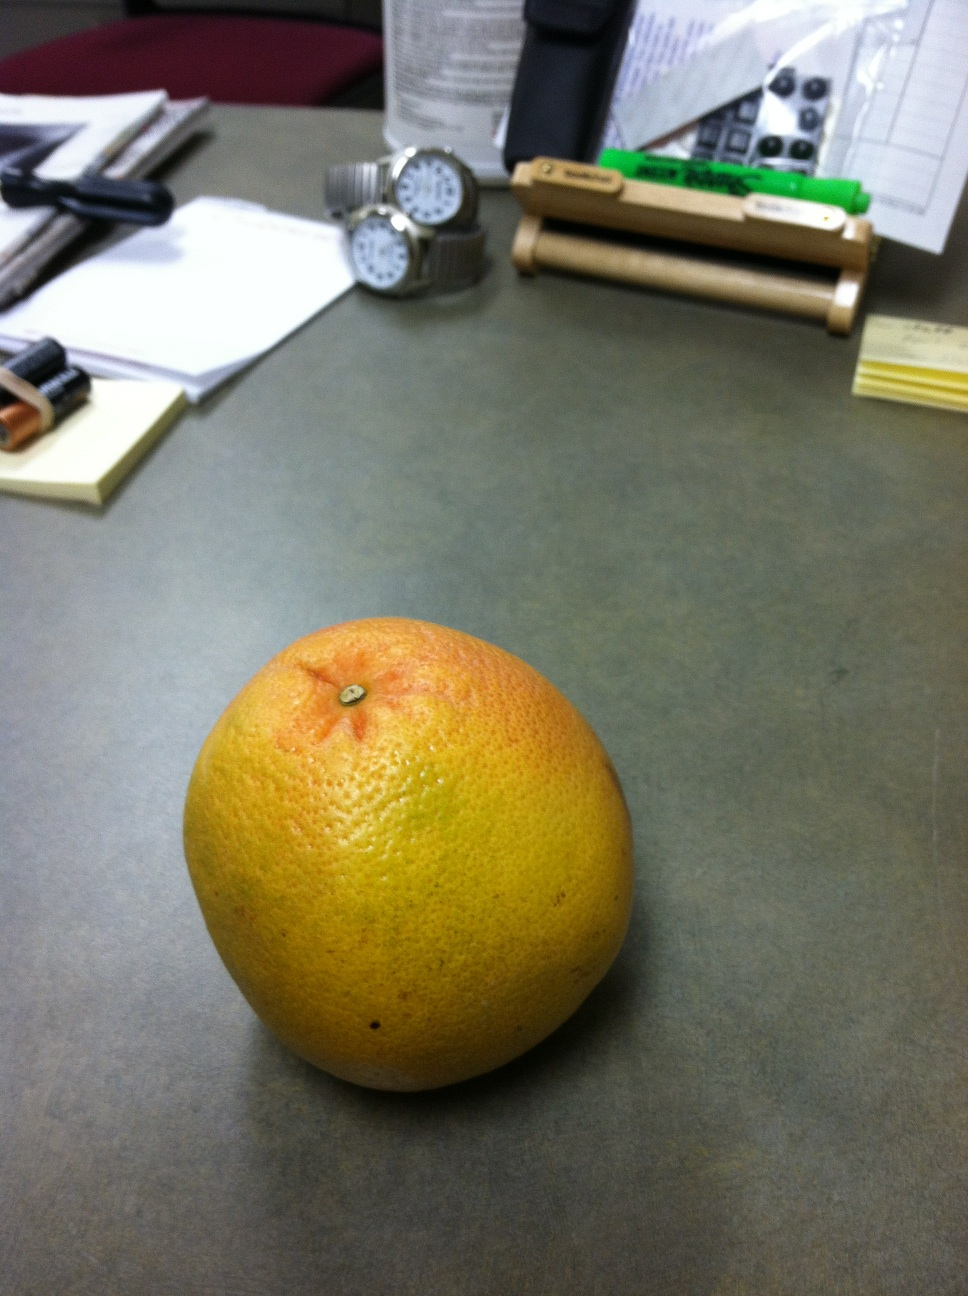Is this fruit ripe enough to eat? From its appearance with a well-rounded shape and rich coloration, it looks ripe and ready to eat. However, ripeness is best confirmed by giving it a gentle squeeze; it should yield slightly under pressure. 